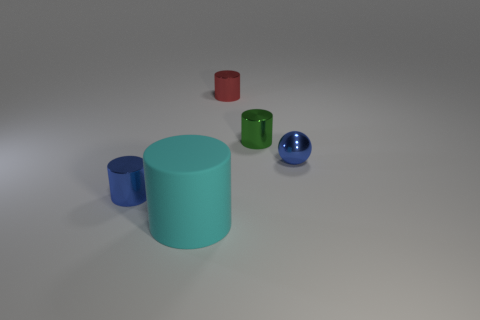Does the small blue thing that is right of the big object have the same shape as the red metallic object that is to the right of the large cylinder?
Keep it short and to the point. No. Are there the same number of spheres behind the green metal thing and cyan things that are behind the big cyan cylinder?
Provide a succinct answer. Yes. There is a blue shiny thing that is in front of the blue metallic thing behind the tiny blue object to the left of the small green metal cylinder; what shape is it?
Make the answer very short. Cylinder. Are the cylinder that is behind the green thing and the tiny object that is to the left of the red thing made of the same material?
Offer a very short reply. Yes. The big thing that is left of the red metallic cylinder has what shape?
Provide a succinct answer. Cylinder. Is the number of red things less than the number of yellow metal cylinders?
Your answer should be compact. No. There is a blue metallic object behind the tiny blue metal thing that is to the left of the green cylinder; are there any matte objects to the right of it?
Your answer should be very brief. No. How many shiny objects are big things or small gray cubes?
Ensure brevity in your answer.  0. Is the big cylinder the same color as the tiny metallic ball?
Offer a terse response. No. What number of red shiny cylinders are in front of the green metallic cylinder?
Ensure brevity in your answer.  0. 